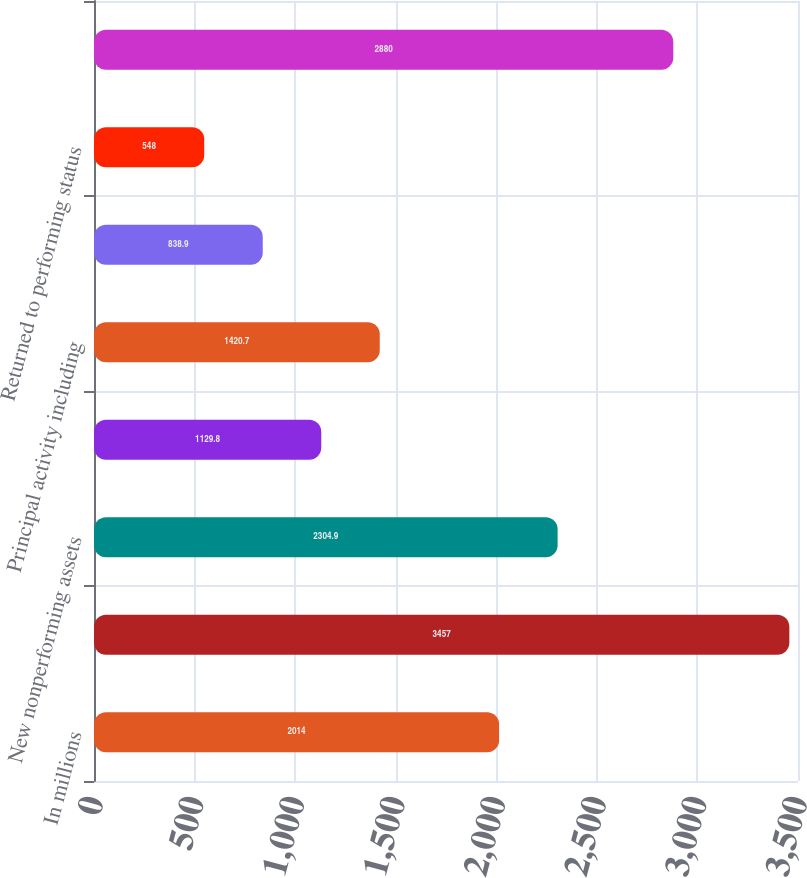Convert chart. <chart><loc_0><loc_0><loc_500><loc_500><bar_chart><fcel>In millions<fcel>January 1<fcel>New nonperforming assets<fcel>Charge-offs and valuation<fcel>Principal activity including<fcel>Asset sales and transfers to<fcel>Returned to performing status<fcel>December 31<nl><fcel>2014<fcel>3457<fcel>2304.9<fcel>1129.8<fcel>1420.7<fcel>838.9<fcel>548<fcel>2880<nl></chart> 